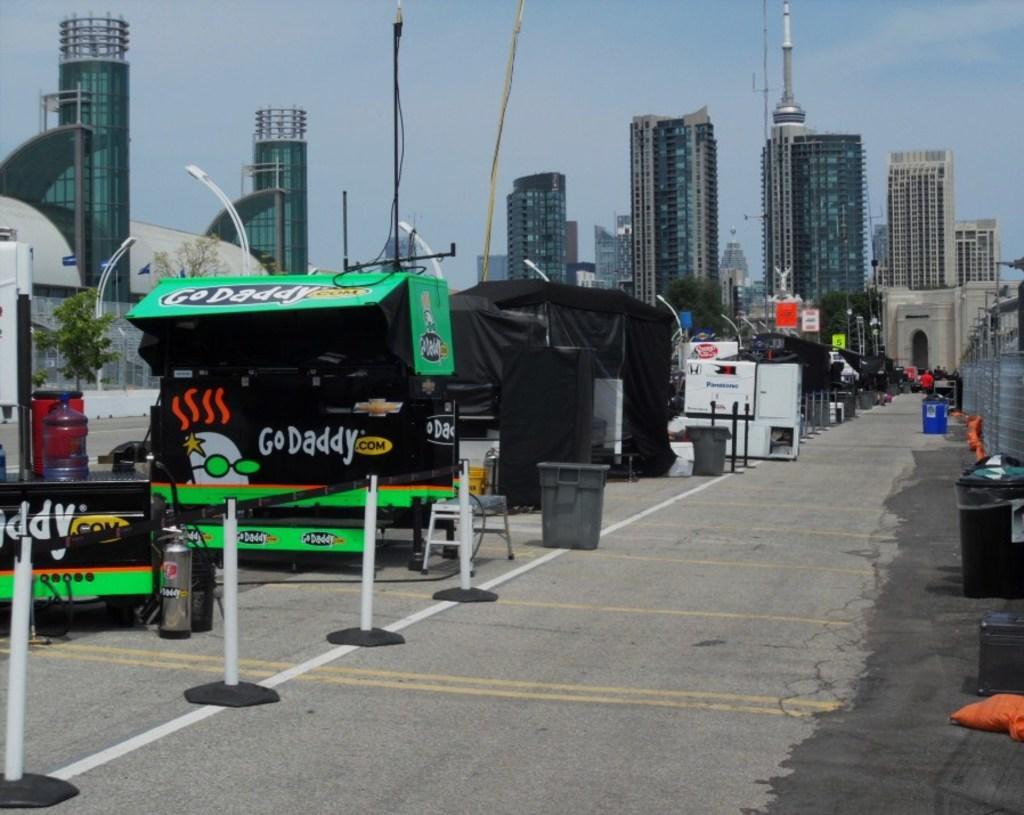How would you summarize this image in a sentence or two? In the picture I can see few objects which has something written on it and there are few dustbins beside it and there are buildings in the background. 